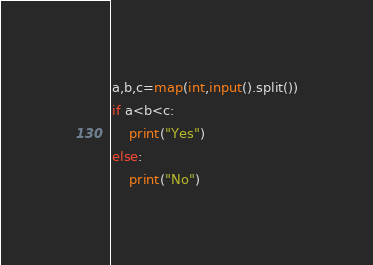Convert code to text. <code><loc_0><loc_0><loc_500><loc_500><_Python_>a,b,c=map(int,input().split())
if a<b<c:
    print("Yes")
else:
    print("No")
</code> 